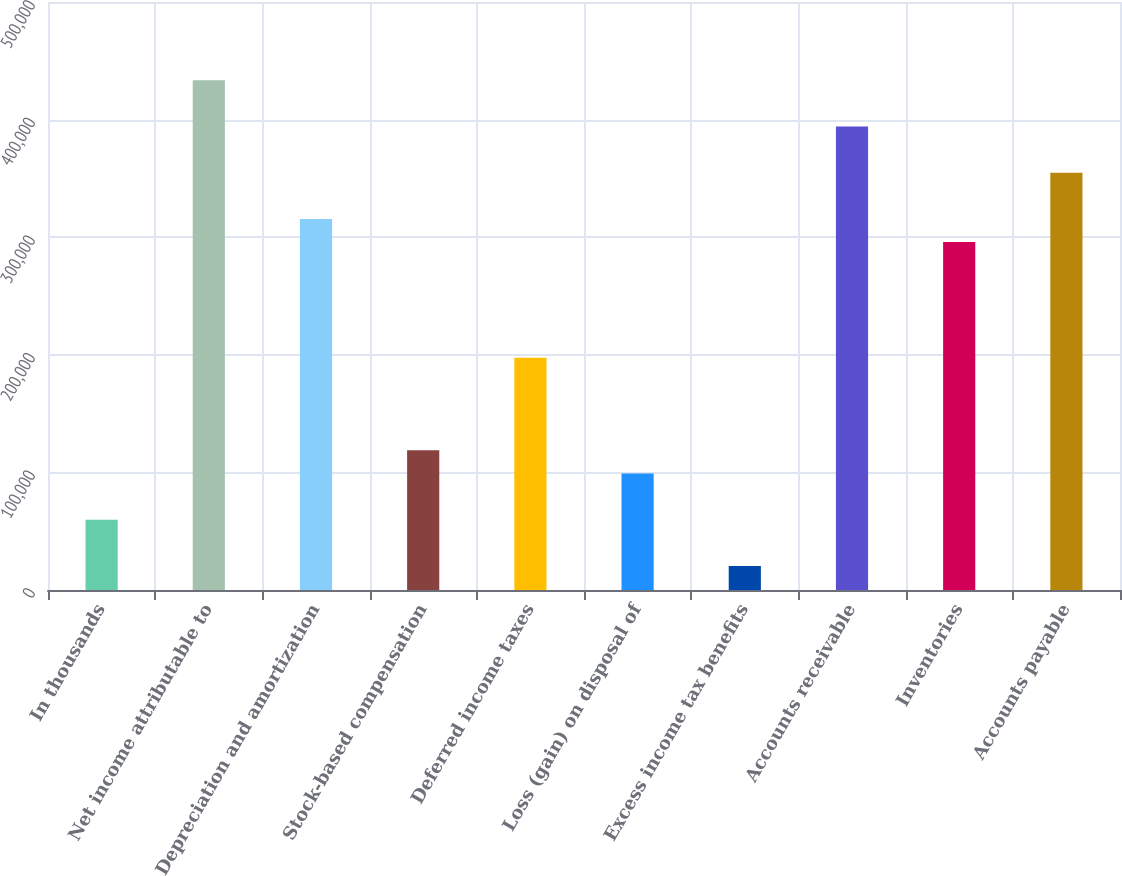Convert chart. <chart><loc_0><loc_0><loc_500><loc_500><bar_chart><fcel>In thousands<fcel>Net income attributable to<fcel>Depreciation and amortization<fcel>Stock-based compensation<fcel>Deferred income taxes<fcel>Loss (gain) on disposal of<fcel>Excess income tax benefits<fcel>Accounts receivable<fcel>Inventories<fcel>Accounts payable<nl><fcel>59838.7<fcel>433491<fcel>315495<fcel>118836<fcel>197500<fcel>99170.5<fcel>20506.9<fcel>394159<fcel>295830<fcel>354827<nl></chart> 